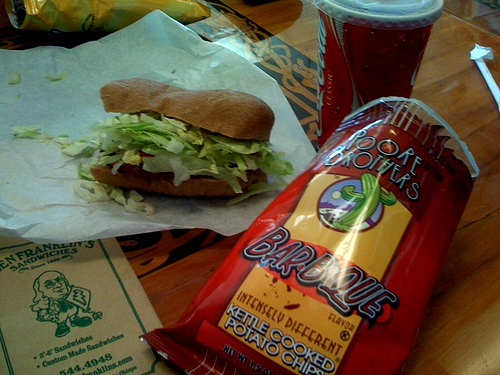What's the flavor of the potato chips? The flavor of the potato chips, according to the packaging, is barbecue. 